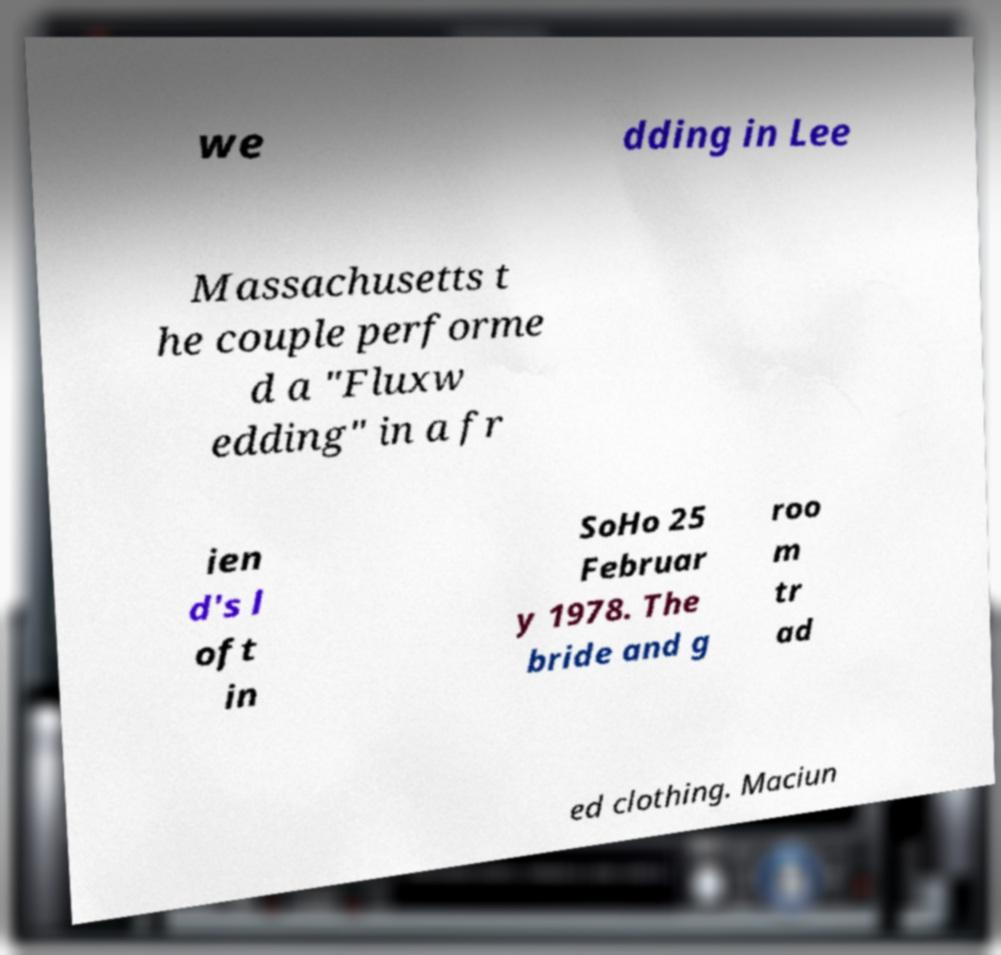Could you assist in decoding the text presented in this image and type it out clearly? we dding in Lee Massachusetts t he couple performe d a "Fluxw edding" in a fr ien d's l oft in SoHo 25 Februar y 1978. The bride and g roo m tr ad ed clothing. Maciun 